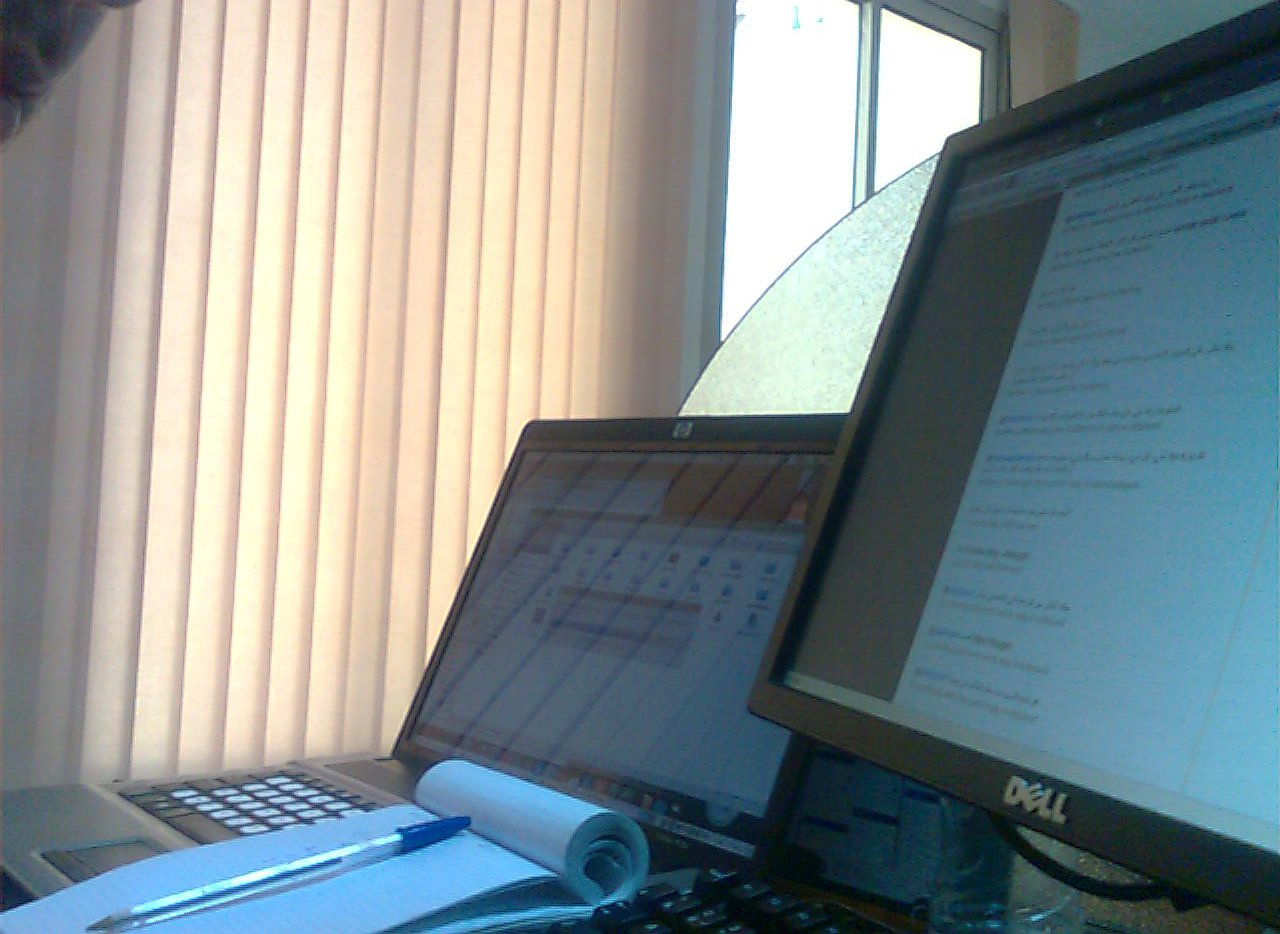Are the blinds to the left of a picture? No, there are no pictures visible next to the blinds; the focus remains on the window covered by the blinds. 